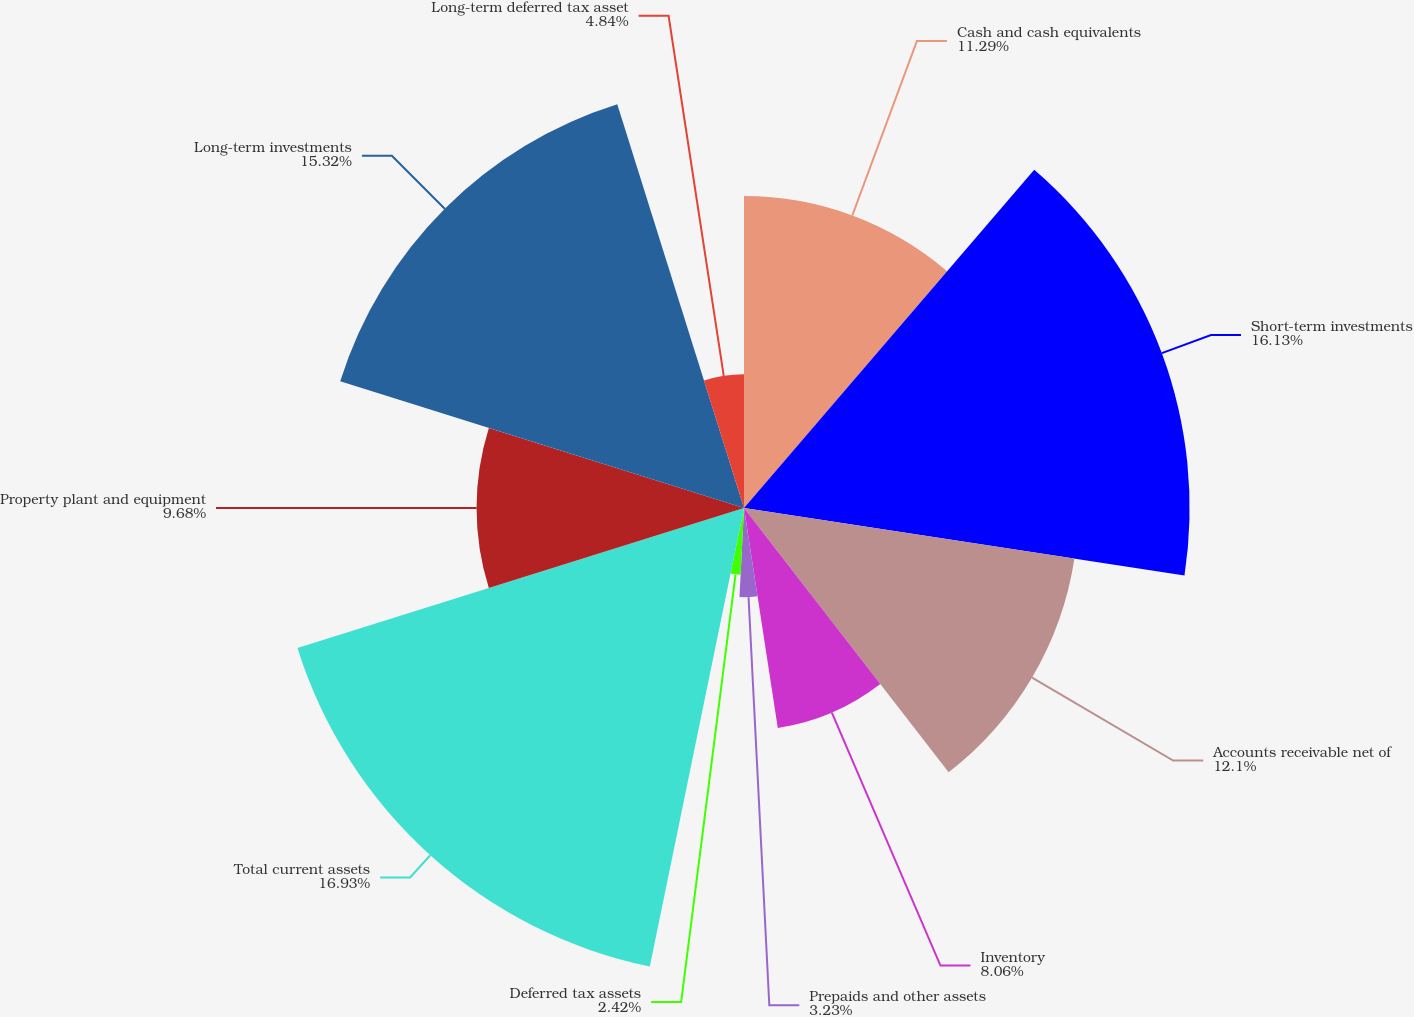Convert chart. <chart><loc_0><loc_0><loc_500><loc_500><pie_chart><fcel>Cash and cash equivalents<fcel>Short-term investments<fcel>Accounts receivable net of<fcel>Inventory<fcel>Prepaids and other assets<fcel>Deferred tax assets<fcel>Total current assets<fcel>Property plant and equipment<fcel>Long-term investments<fcel>Long-term deferred tax asset<nl><fcel>11.29%<fcel>16.13%<fcel>12.1%<fcel>8.06%<fcel>3.23%<fcel>2.42%<fcel>16.94%<fcel>9.68%<fcel>15.32%<fcel>4.84%<nl></chart> 